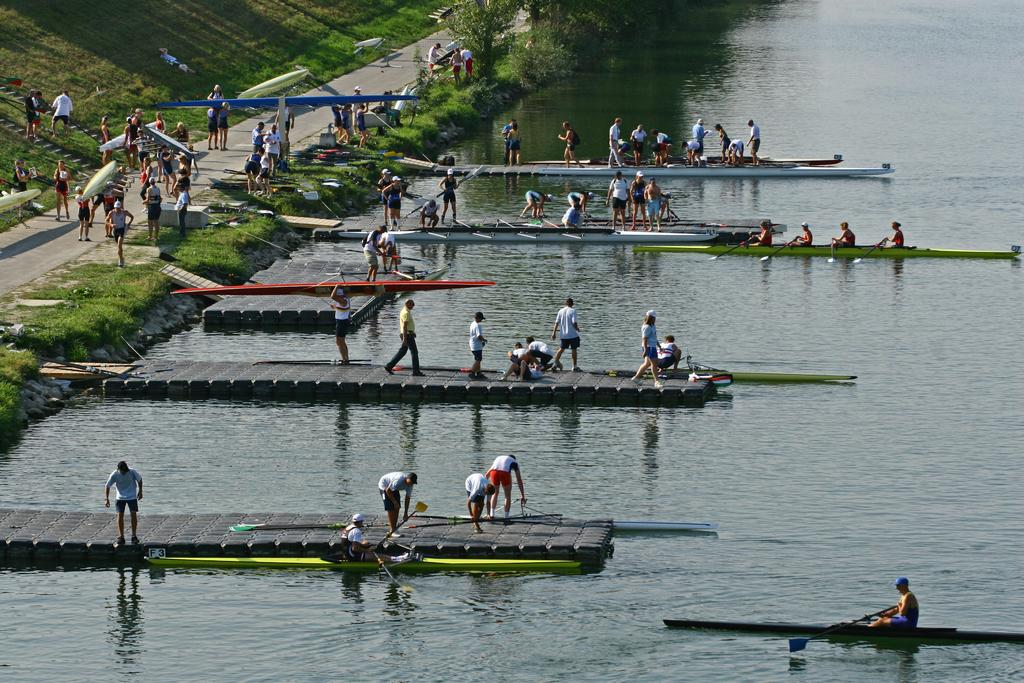What type of vegetation is present towards the left side of the image? There is grass towards the left side of the image. What other natural elements can be seen in the image? There are trees in the image. What is the boat being used for in the image? There are persons holding the boat and rowing it. What body of water is present in the image? There is a river in the image. Can you see any clouds in the image? There is no mention of clouds in the provided facts, so we cannot definitively say whether clouds are present in the image or not. What items are on the list that the persons are holding in the image? There is no list mentioned in the provided facts, so we cannot answer this question. 